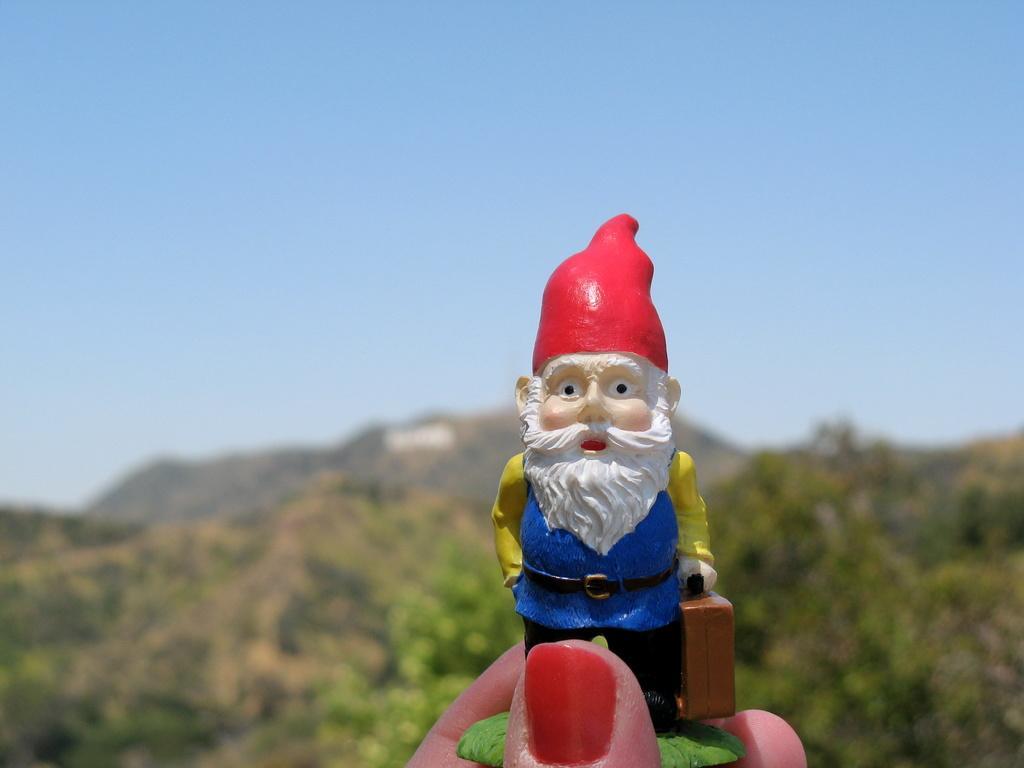Can you describe this image briefly? In this image we can see the hand of a person holding a toy. In the background there are trees, mountains and the sky. 